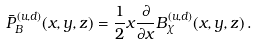<formula> <loc_0><loc_0><loc_500><loc_500>\bar { P } _ { B } ^ { ( u , d ) } ( x , y , z ) = \frac { 1 } { 2 } x \frac { \partial } { \partial x } B ^ { ( u , d ) } _ { \chi } ( x , y , z ) \, .</formula> 